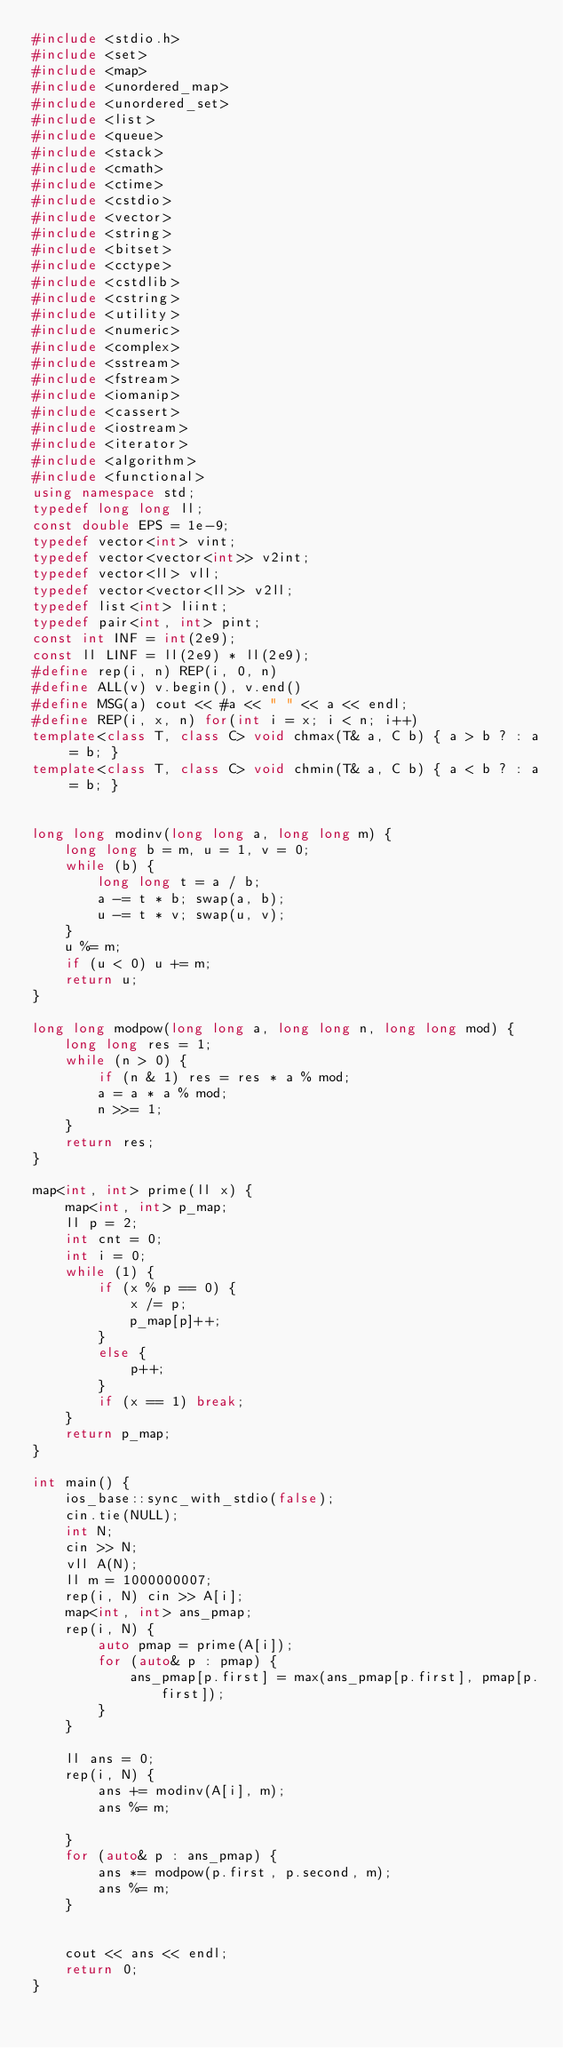Convert code to text. <code><loc_0><loc_0><loc_500><loc_500><_C++_>#include <stdio.h>
#include <set>
#include <map>
#include <unordered_map>
#include <unordered_set>
#include <list>
#include <queue>
#include <stack>
#include <cmath>
#include <ctime>
#include <cstdio>
#include <vector>
#include <string>
#include <bitset>
#include <cctype>
#include <cstdlib>
#include <cstring>
#include <utility>
#include <numeric>
#include <complex>
#include <sstream>
#include <fstream>
#include <iomanip>
#include <cassert>
#include <iostream>
#include <iterator>
#include <algorithm>
#include <functional>
using namespace std;
typedef long long ll;
const double EPS = 1e-9;
typedef vector<int> vint;
typedef vector<vector<int>> v2int;
typedef vector<ll> vll;
typedef vector<vector<ll>> v2ll;
typedef list<int> liint;
typedef pair<int, int> pint;
const int INF = int(2e9);
const ll LINF = ll(2e9) * ll(2e9);
#define rep(i, n) REP(i, 0, n)
#define ALL(v) v.begin(), v.end()
#define MSG(a) cout << #a << " " << a << endl;
#define REP(i, x, n) for(int i = x; i < n; i++)
template<class T, class C> void chmax(T& a, C b) { a > b ? : a = b; }
template<class T, class C> void chmin(T& a, C b) { a < b ? : a = b; }


long long modinv(long long a, long long m) {
    long long b = m, u = 1, v = 0;
    while (b) {
        long long t = a / b;
        a -= t * b; swap(a, b);
        u -= t * v; swap(u, v);
    }
    u %= m;
    if (u < 0) u += m;
    return u;
}

long long modpow(long long a, long long n, long long mod) {
    long long res = 1;
    while (n > 0) {
        if (n & 1) res = res * a % mod;
        a = a * a % mod;
        n >>= 1;
    }
    return res;
}

map<int, int> prime(ll x) {
    map<int, int> p_map;
    ll p = 2;
    int cnt = 0;
    int i = 0;
    while (1) {
        if (x % p == 0) {
            x /= p;
            p_map[p]++;
        }
        else {
            p++;
        }
        if (x == 1) break;
    }
    return p_map;
}

int main() {
    ios_base::sync_with_stdio(false);
    cin.tie(NULL);
    int N;
    cin >> N;
    vll A(N);
    ll m = 1000000007;
    rep(i, N) cin >> A[i];
    map<int, int> ans_pmap;
    rep(i, N) {
        auto pmap = prime(A[i]);
        for (auto& p : pmap) {
            ans_pmap[p.first] = max(ans_pmap[p.first], pmap[p.first]);
        }
    }

    ll ans = 0;
    rep(i, N) {
        ans += modinv(A[i], m);
        ans %= m;

    }
    for (auto& p : ans_pmap) {
        ans *= modpow(p.first, p.second, m);
        ans %= m;
    }
    

    cout << ans << endl;
    return 0;
}</code> 